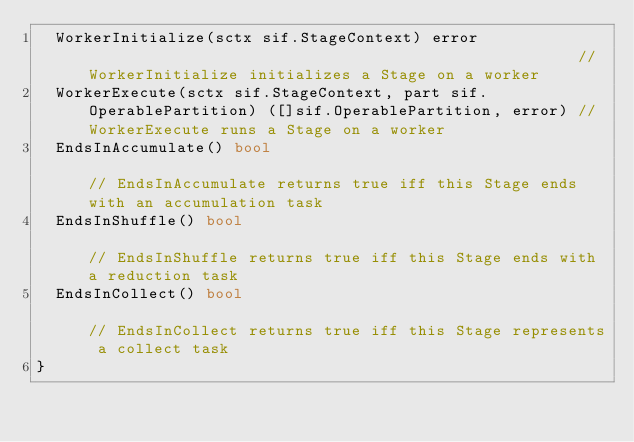Convert code to text. <code><loc_0><loc_0><loc_500><loc_500><_Go_>	WorkerInitialize(sctx sif.StageContext) error                                                     // WorkerInitialize initializes a Stage on a worker
	WorkerExecute(sctx sif.StageContext, part sif.OperablePartition) ([]sif.OperablePartition, error) // WorkerExecute runs a Stage on a worker
	EndsInAccumulate() bool                                                                           // EndsInAccumulate returns true iff this Stage ends with an accumulation task
	EndsInShuffle() bool                                                                              // EndsInShuffle returns true iff this Stage ends with a reduction task
	EndsInCollect() bool                                                                              // EndsInCollect returns true iff this Stage represents a collect task
}
</code> 